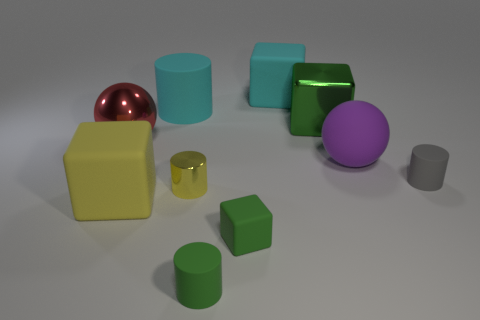Does the cylinder behind the red ball have the same material as the large cube that is in front of the big purple ball?
Offer a terse response. Yes. There is a green block left of the cyan rubber cube; is it the same size as the red thing?
Offer a terse response. No. Do the metallic block and the big ball that is right of the small yellow shiny cylinder have the same color?
Your answer should be compact. No. There is another object that is the same color as the small metallic thing; what is its shape?
Give a very brief answer. Cube. The tiny gray object has what shape?
Your answer should be very brief. Cylinder. Is the color of the big shiny cube the same as the shiny cylinder?
Ensure brevity in your answer.  No. What number of things are rubber blocks in front of the small yellow shiny thing or large cyan rubber blocks?
Ensure brevity in your answer.  3. What size is the green thing that is the same material as the big red object?
Your answer should be very brief. Large. Is the number of big purple matte spheres on the left side of the rubber sphere greater than the number of small green blocks?
Make the answer very short. No. There is a red metallic object; does it have the same shape as the green thing behind the gray cylinder?
Provide a succinct answer. No. 